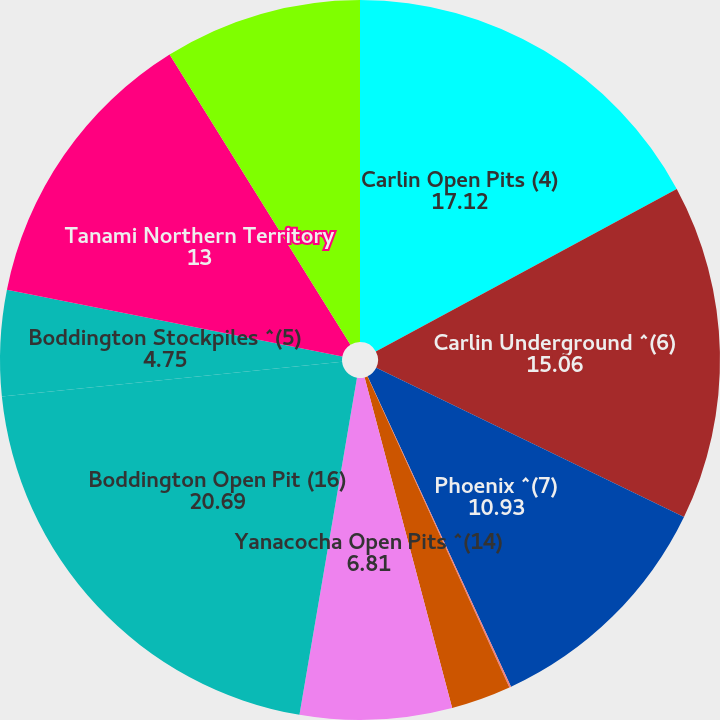<chart> <loc_0><loc_0><loc_500><loc_500><pie_chart><fcel>Carlin Open Pits (4)<fcel>Carlin Underground ^(6)<fcel>Phoenix ^(7)<fcel>Lone Tree ^(8)<fcel>Turquoise Ridge ^(9)<fcel>Yanacocha Open Pits ^(14)<fcel>Boddington Open Pit (16)<fcel>Boddington Stockpiles ^(5)<fcel>Tanami Northern Territory<fcel>Ahafo South Open Pits ^(19)<nl><fcel>17.12%<fcel>15.06%<fcel>10.93%<fcel>0.08%<fcel>2.69%<fcel>6.81%<fcel>20.69%<fcel>4.75%<fcel>13.0%<fcel>8.87%<nl></chart> 